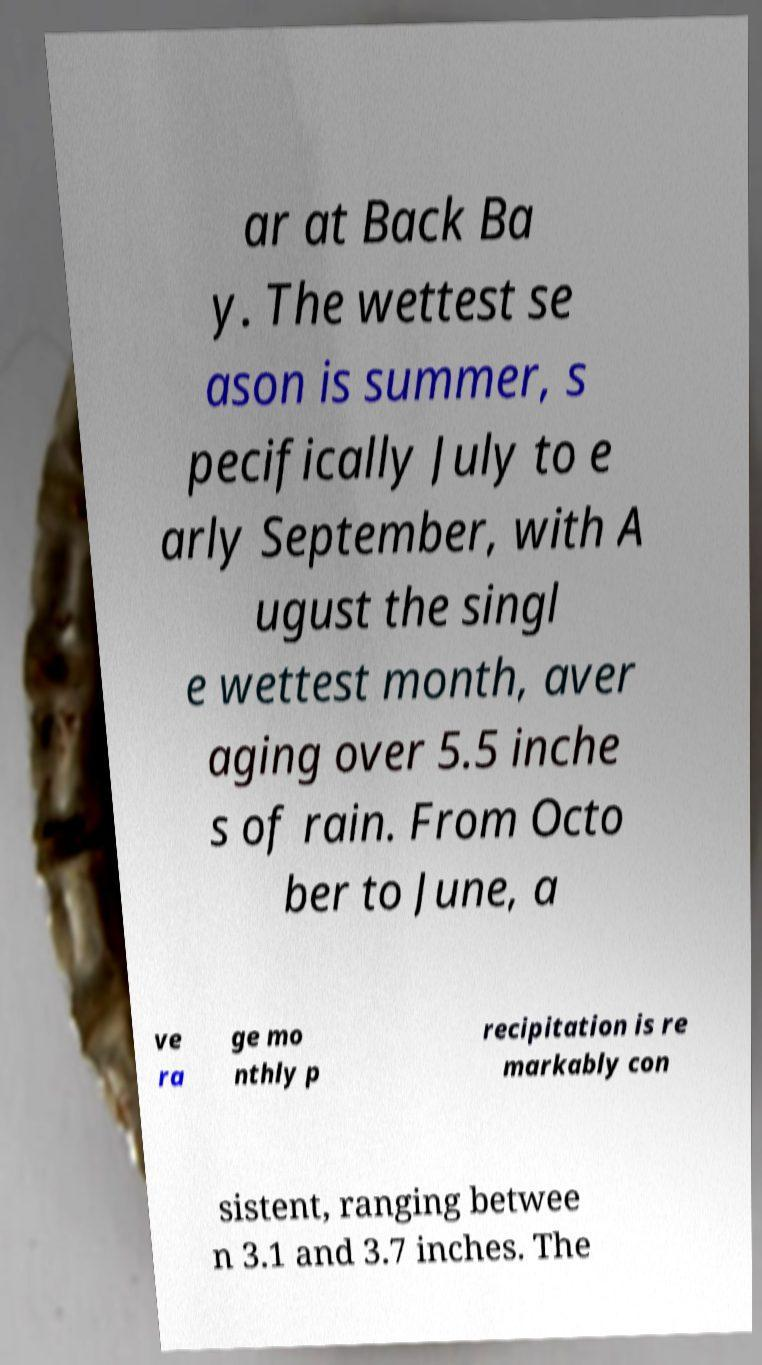For documentation purposes, I need the text within this image transcribed. Could you provide that? ar at Back Ba y. The wettest se ason is summer, s pecifically July to e arly September, with A ugust the singl e wettest month, aver aging over 5.5 inche s of rain. From Octo ber to June, a ve ra ge mo nthly p recipitation is re markably con sistent, ranging betwee n 3.1 and 3.7 inches. The 